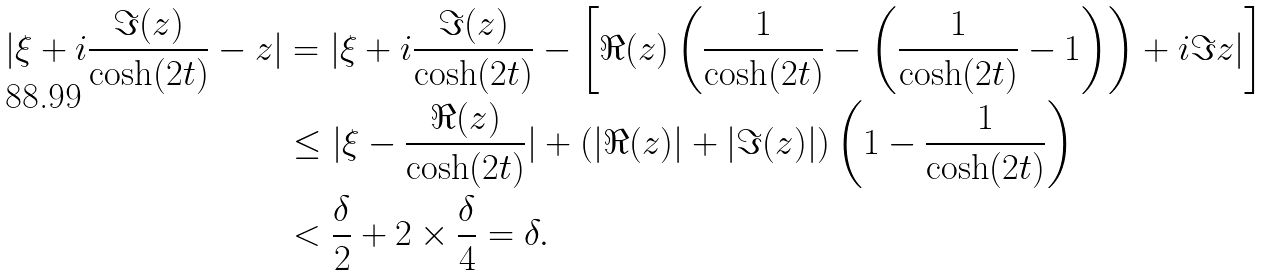<formula> <loc_0><loc_0><loc_500><loc_500>| \xi + i \frac { \Im ( z ) } { \cosh ( 2 t ) } - z | & = | \xi + i \frac { \Im ( z ) } { \cosh ( 2 t ) } - \left [ \Re ( z ) \left ( \frac { 1 } { \cosh ( 2 t ) } - \left ( \frac { 1 } { \cosh ( 2 t ) } - 1 \right ) \right ) + i \Im z | \right ] \\ & \leq | \xi - \frac { \Re ( z ) } { \cosh ( 2 t ) } | + ( | \Re ( z ) | + | \Im ( z ) | ) \left ( 1 - \frac { 1 } { \cosh ( 2 t ) } \right ) \\ & < \frac { \delta } { 2 } + 2 \times \frac { \delta } { 4 } = \delta .</formula> 